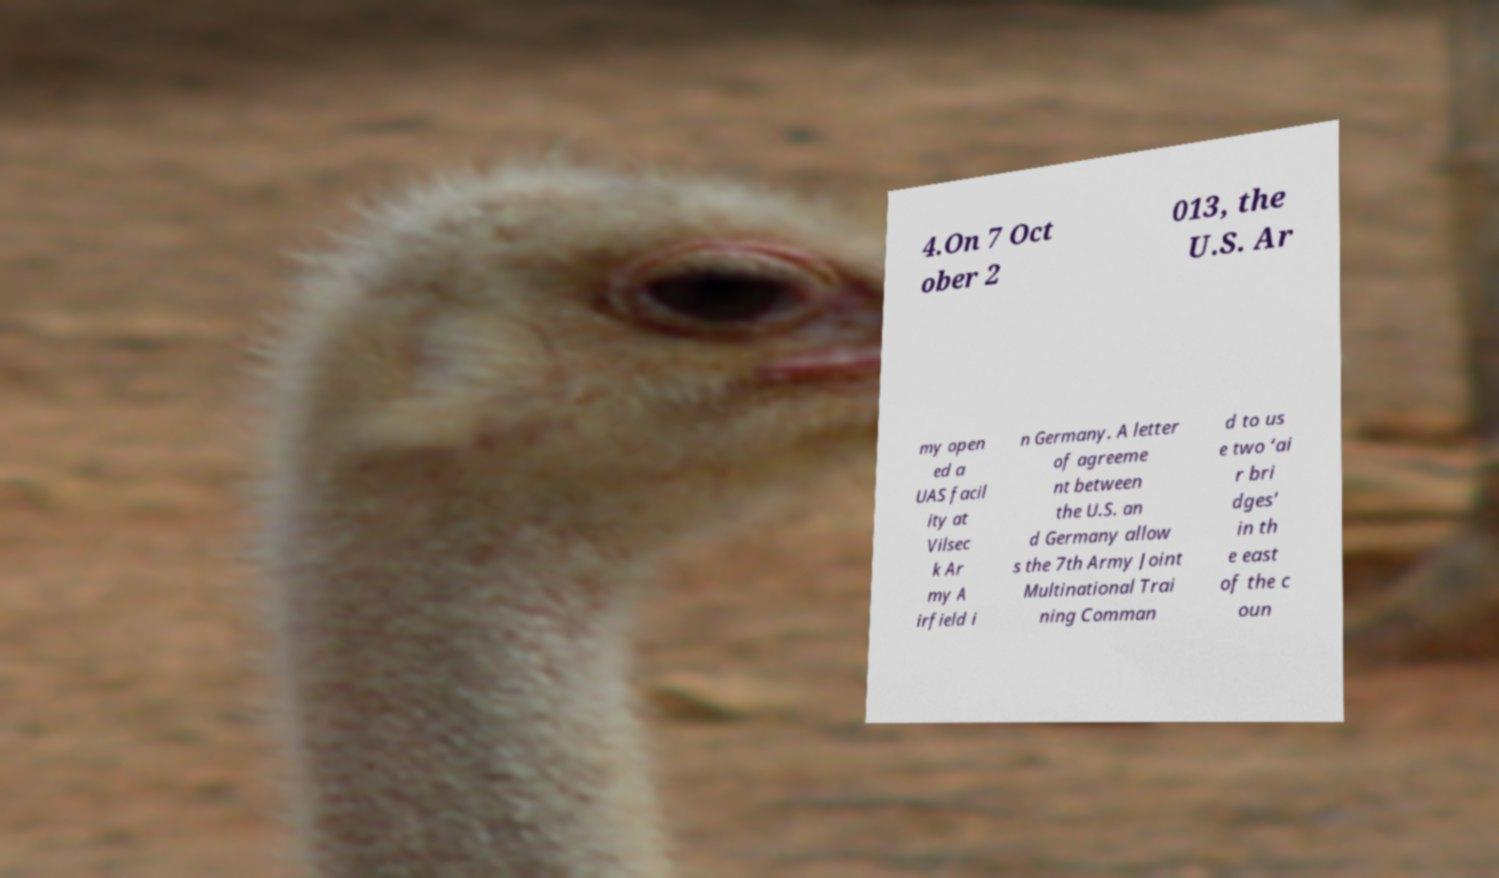Could you extract and type out the text from this image? 4.On 7 Oct ober 2 013, the U.S. Ar my open ed a UAS facil ity at Vilsec k Ar my A irfield i n Germany. A letter of agreeme nt between the U.S. an d Germany allow s the 7th Army Joint Multinational Trai ning Comman d to us e two ‘ai r bri dges’ in th e east of the c oun 